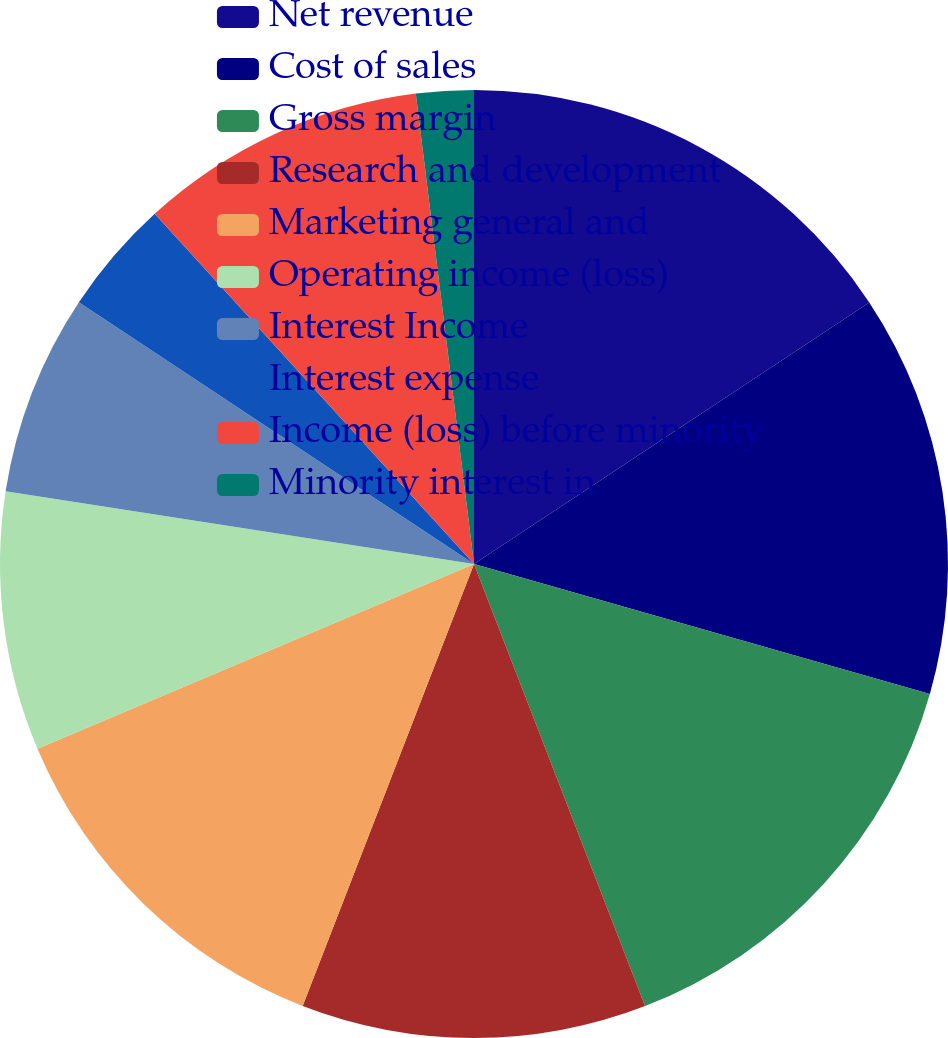<chart> <loc_0><loc_0><loc_500><loc_500><pie_chart><fcel>Net revenue<fcel>Cost of sales<fcel>Gross margin<fcel>Research and development<fcel>Marketing general and<fcel>Operating income (loss)<fcel>Interest Income<fcel>Interest expense<fcel>Income (loss) before minority<fcel>Minority interest in<nl><fcel>15.69%<fcel>13.72%<fcel>14.7%<fcel>11.76%<fcel>12.74%<fcel>8.82%<fcel>6.86%<fcel>3.92%<fcel>9.8%<fcel>1.96%<nl></chart> 